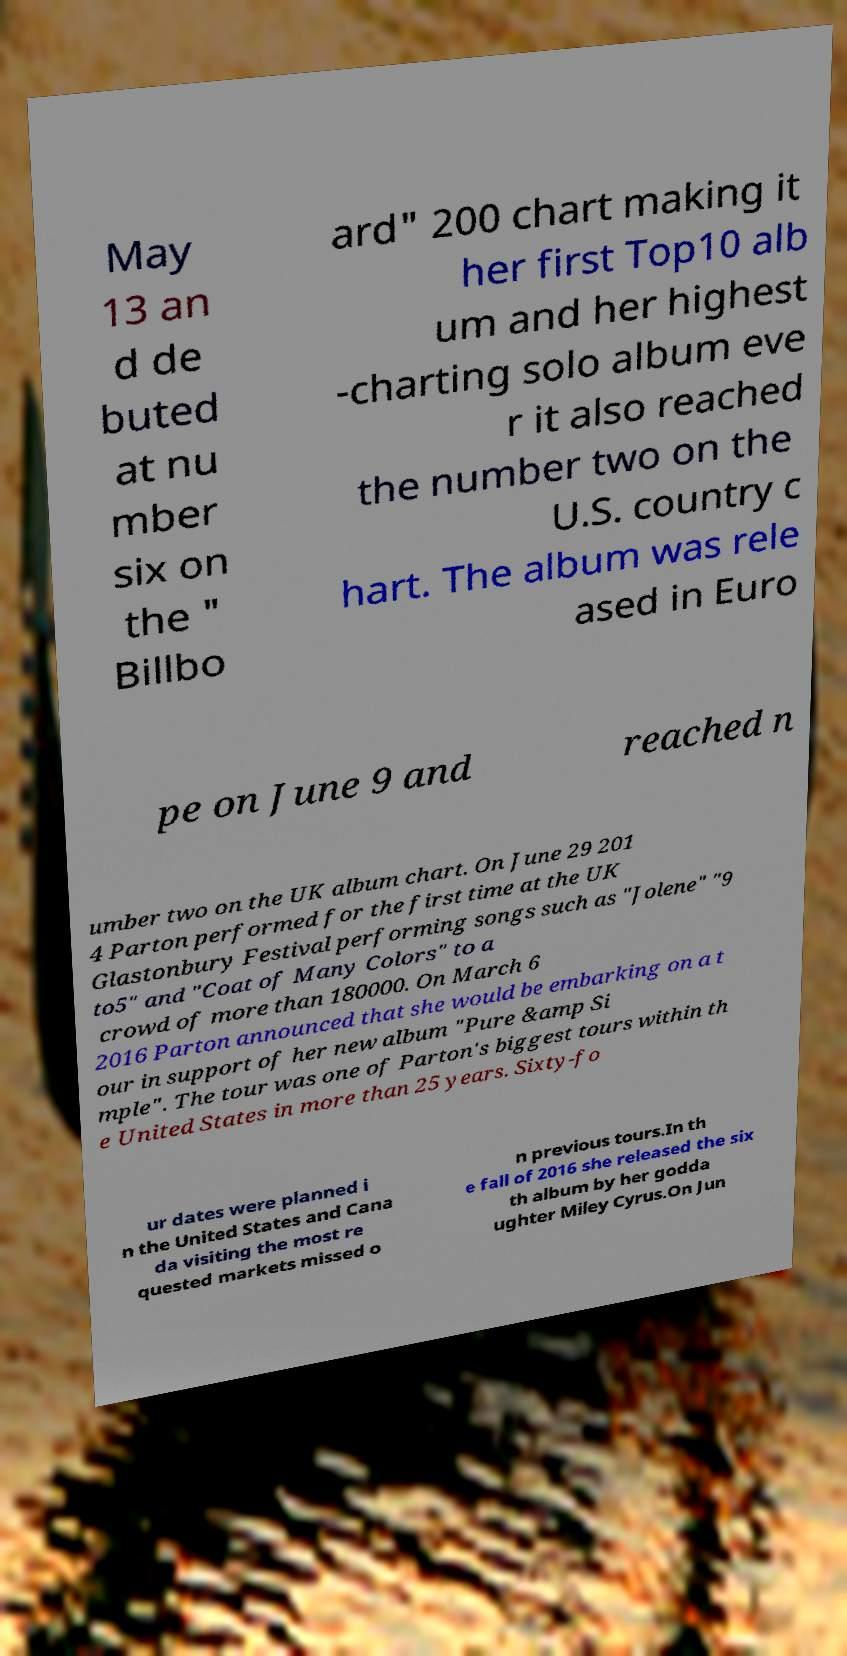For documentation purposes, I need the text within this image transcribed. Could you provide that? May 13 an d de buted at nu mber six on the " Billbo ard" 200 chart making it her first Top10 alb um and her highest -charting solo album eve r it also reached the number two on the U.S. country c hart. The album was rele ased in Euro pe on June 9 and reached n umber two on the UK album chart. On June 29 201 4 Parton performed for the first time at the UK Glastonbury Festival performing songs such as "Jolene" "9 to5" and "Coat of Many Colors" to a crowd of more than 180000. On March 6 2016 Parton announced that she would be embarking on a t our in support of her new album "Pure &amp Si mple". The tour was one of Parton's biggest tours within th e United States in more than 25 years. Sixty-fo ur dates were planned i n the United States and Cana da visiting the most re quested markets missed o n previous tours.In th e fall of 2016 she released the six th album by her godda ughter Miley Cyrus.On Jun 